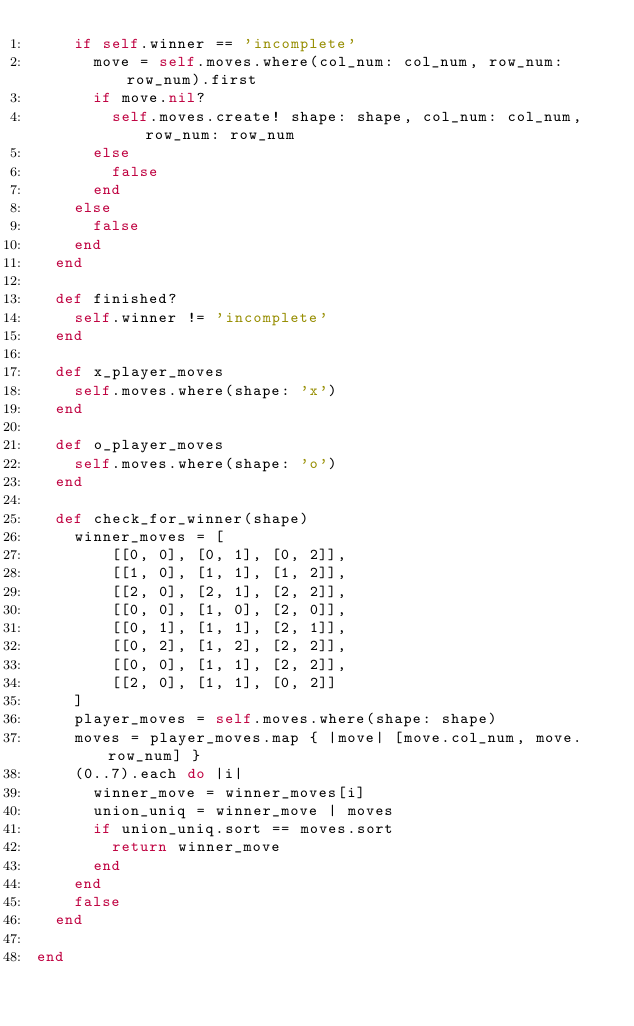<code> <loc_0><loc_0><loc_500><loc_500><_Ruby_>    if self.winner == 'incomplete'
      move = self.moves.where(col_num: col_num, row_num: row_num).first
      if move.nil?
        self.moves.create! shape: shape, col_num: col_num, row_num: row_num
      else
        false
      end
    else
      false
    end
  end

  def finished?
    self.winner != 'incomplete'
  end

  def x_player_moves
    self.moves.where(shape: 'x')
  end

  def o_player_moves
    self.moves.where(shape: 'o')
  end

  def check_for_winner(shape)
    winner_moves = [
        [[0, 0], [0, 1], [0, 2]],
        [[1, 0], [1, 1], [1, 2]],
        [[2, 0], [2, 1], [2, 2]],
        [[0, 0], [1, 0], [2, 0]],
        [[0, 1], [1, 1], [2, 1]],
        [[0, 2], [1, 2], [2, 2]],
        [[0, 0], [1, 1], [2, 2]],
        [[2, 0], [1, 1], [0, 2]]
    ]
    player_moves = self.moves.where(shape: shape)
    moves = player_moves.map { |move| [move.col_num, move.row_num] }
    (0..7).each do |i|
      winner_move = winner_moves[i]
      union_uniq = winner_move | moves
      if union_uniq.sort == moves.sort
        return winner_move
      end
    end
    false
  end

end
</code> 